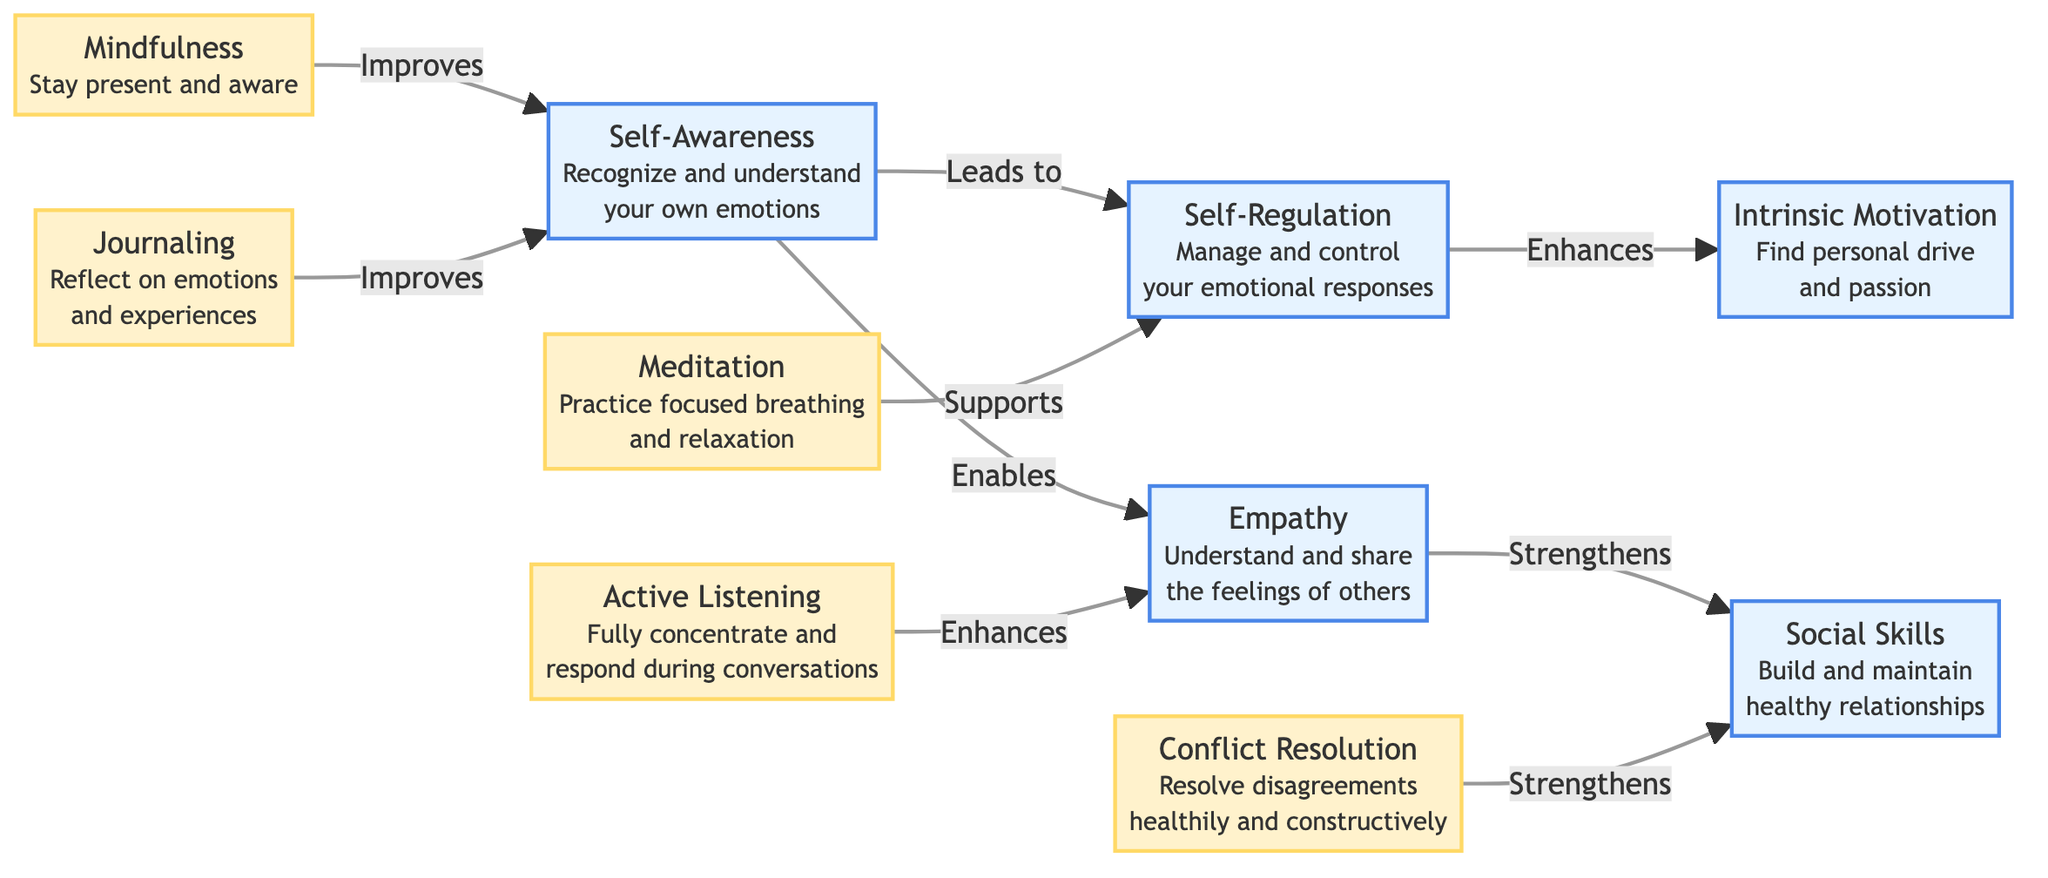What are the core skills highlighted in the diagram? The diagram lists five core skills: Self-Awareness, Self-Regulation, Empathy, Social Skills, and Intrinsic Motivation. These are explicitly named as core skills within the structure of the diagram.
Answer: Self-Awareness, Self-Regulation, Empathy, Social Skills, Intrinsic Motivation Which activity leads to improved self-regulation? The diagram indicates that meditation supports self-regulation, showing a direct link between the activity of meditation and the core skill of self-regulation.
Answer: Meditation How many activities are listed in the diagram? There are five activities mentioned in the diagram: Mindfulness, Active Listening, Journaling, Meditation, and Conflict Resolution. This count is derived by identifying all activity nodes.
Answer: Five What does empathy enhance according to the diagram? The diagram states that empathy strengthens social skills, showcasing a direct relationship between the core skill of empathy and the social skills it enhances.
Answer: Social Skills Which activity is responsible for strengthening social skills? The diagram shows that Conflict Resolution is the activity that strengthens social skills, illustrating the direct connection between them in the flow of the diagram.
Answer: Conflict Resolution Can you name an activity that improves self-awareness? The diagram lists two activities that improve self-awareness: Mindfulness and Journaling. Both are linked to the self-awareness skill and indicate their contributions to it.
Answer: Mindfulness, Journaling What is the relationship between self-awareness and empathy? The diagram indicates that self-awareness enables empathy, which demonstrates that recognizing and understanding one's own emotions is foundational for understanding and sharing the feelings of others.
Answer: Enables What enhances motivation according to the diagram? The diagram indicates that self-regulation enhances motivation, showing a direct link from managing emotional responses to finding personal drive and passion.
Answer: Self-Regulation Which skill leads to intrinsic motivation? The diagram states that self-regulation enhances intrinsic motivation, which reflects the progression from emotional control to personal drive and passion.
Answer: Self-Regulation 